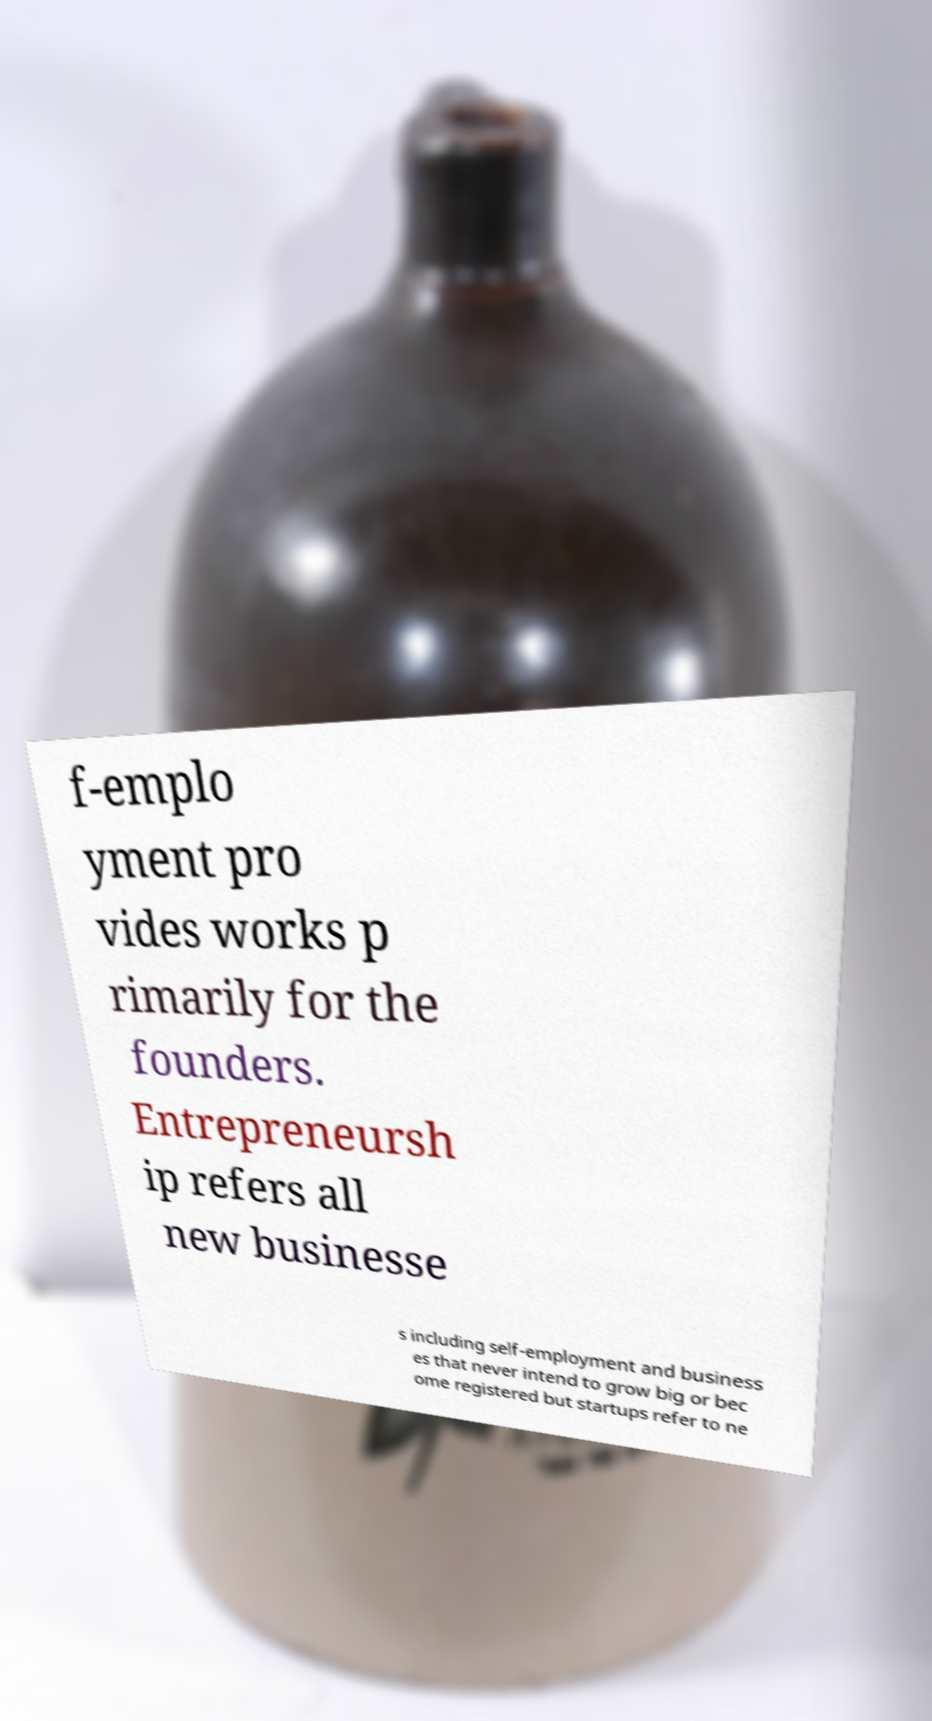Can you read and provide the text displayed in the image?This photo seems to have some interesting text. Can you extract and type it out for me? f-emplo yment pro vides works p rimarily for the founders. Entrepreneursh ip refers all new businesse s including self-employment and business es that never intend to grow big or bec ome registered but startups refer to ne 